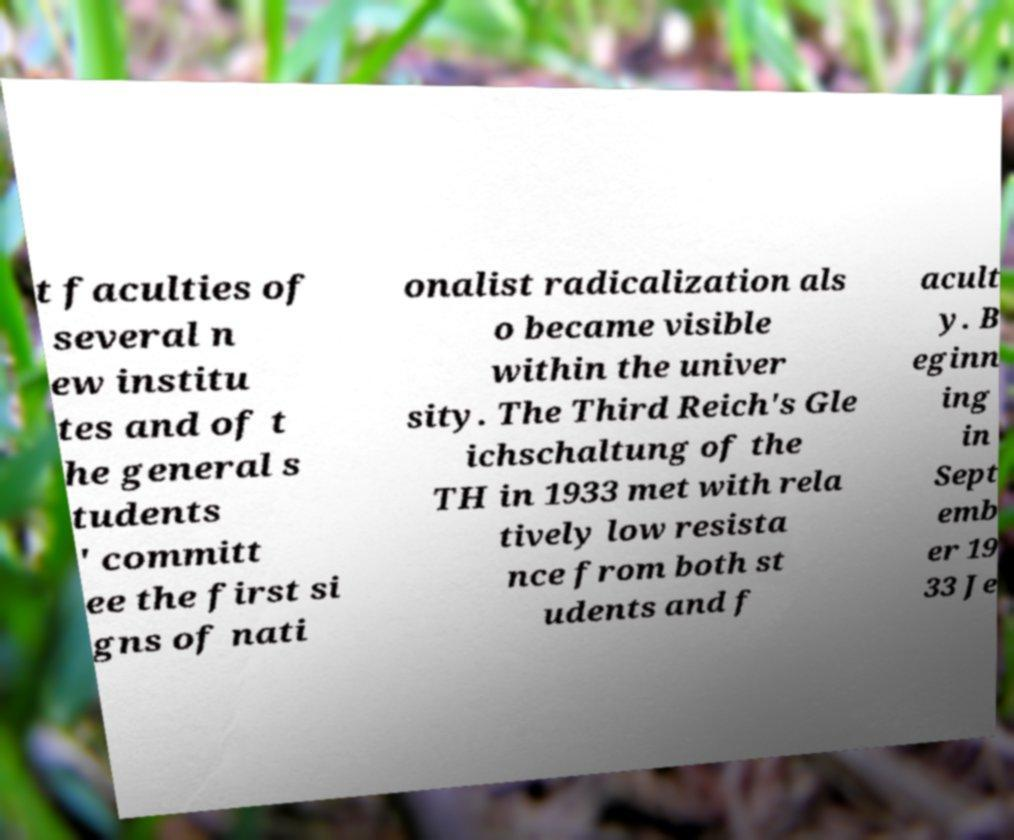Please identify and transcribe the text found in this image. t faculties of several n ew institu tes and of t he general s tudents ' committ ee the first si gns of nati onalist radicalization als o became visible within the univer sity. The Third Reich's Gle ichschaltung of the TH in 1933 met with rela tively low resista nce from both st udents and f acult y. B eginn ing in Sept emb er 19 33 Je 